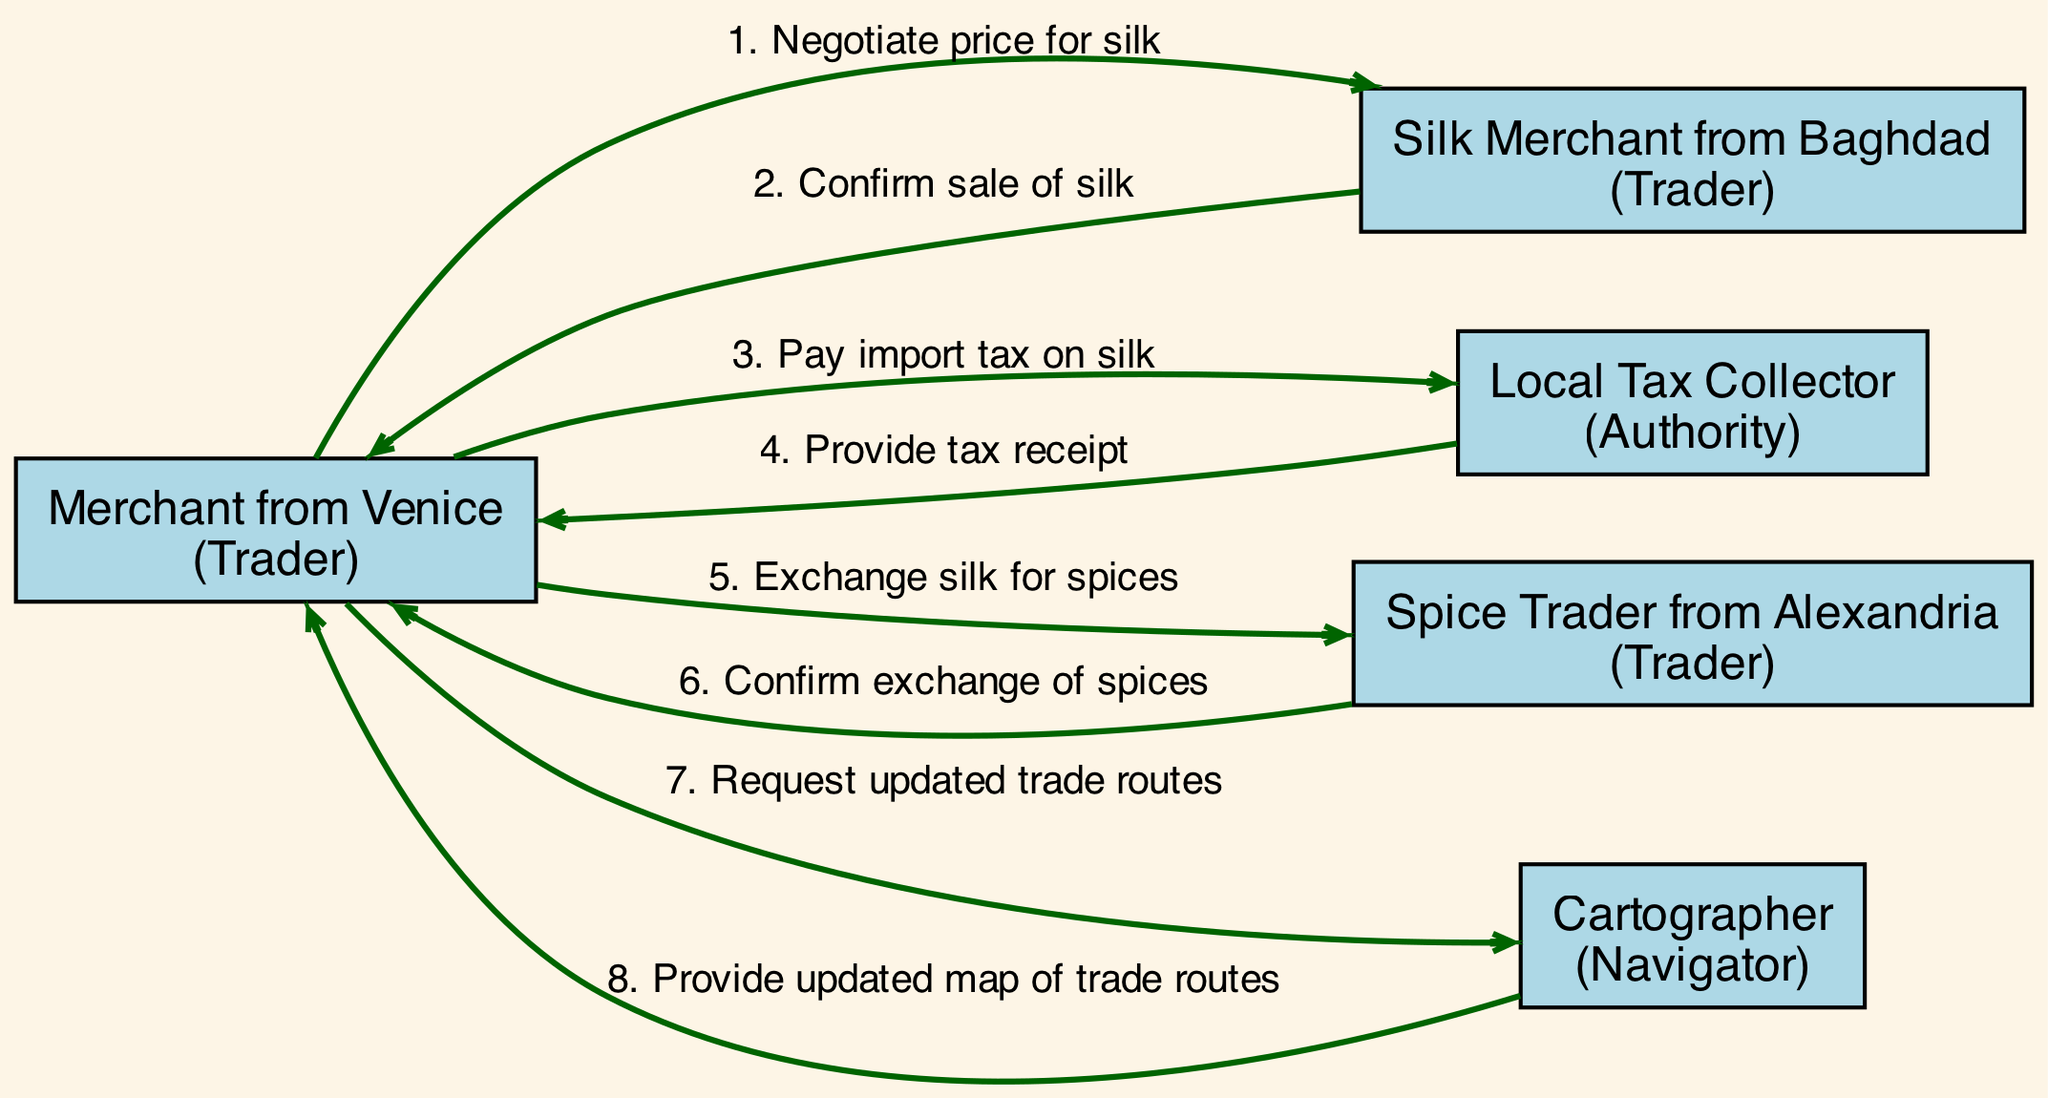What is the role of the Silk Merchant from Baghdad? The diagram labels the Silk Merchant as a "Trader," which is one of the participant roles listed.
Answer: Trader How many participants are involved in the diagram? By counting the entries in the participants section, there are five participants mentioned: Merchant from Venice, Silk Merchant from Baghdad, Local Tax Collector, Spice Trader from Alexandria, and Cartographer.
Answer: 5 What message does the Local Tax Collector send to the Merchant from Venice? Referring to the interaction from Local Tax Collector to Merchant from Venice, the message displayed is "Provide tax receipt."
Answer: Provide tax receipt What is the first interaction that occurs in the diagram? By examining the interactions, the first one is from Merchant from Venice to Silk Merchant from Baghdad, where the message is "Negotiate price for silk."
Answer: Negotiate price for silk Which participant interacts with the Cartographer? Only the Merchant from Venice is shown sending a request to the Cartographer, making this the only interaction with this participant.
Answer: Merchant from Venice Identify the type of interaction involving the Local Tax Collector. The Local Tax Collector is indicated as having an interaction with the Merchant from Venice where the message is about paying import tax, which is an official transaction.
Answer: Authority transaction How many exchanges of goods (silk for spices) take place in the diagram? The interactions clearly show one exchange where the Merchant from Venice exchanges silk for spices with the Spice Trader from Alexandria and confirms it in a following message, indicating one complete transaction.
Answer: 1 What confirmation does the Silk Merchant from Baghdad provide? The interaction clearly states that the Silk Merchant from Baghdad sends a message confirming the sale of silk to the Merchant from Venice.
Answer: Confirm sale of silk Which trader requests updated trade routes? Upon reviewing the interactions, it is evident that the Merchant from Venice is the only participant who requests updated trade routes.
Answer: Merchant from Venice 